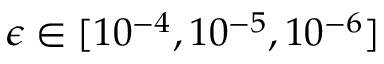<formula> <loc_0><loc_0><loc_500><loc_500>\epsilon \in [ 1 0 ^ { - 4 } , 1 0 ^ { - 5 } , 1 0 ^ { - 6 } ]</formula> 